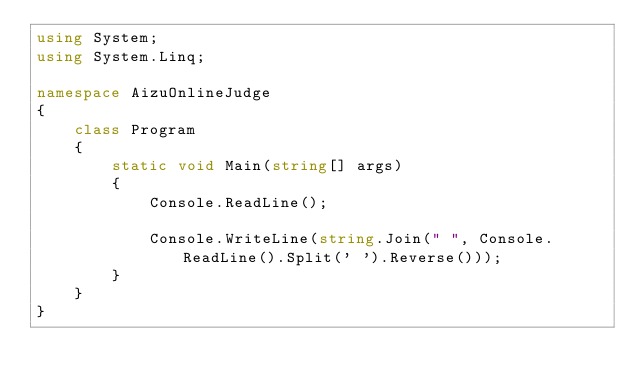Convert code to text. <code><loc_0><loc_0><loc_500><loc_500><_C#_>using System;
using System.Linq;

namespace AizuOnlineJudge
{
    class Program
    {
        static void Main(string[] args)
        {
            Console.ReadLine();

            Console.WriteLine(string.Join(" ", Console.ReadLine().Split(' ').Reverse()));
        }
    }
}
</code> 